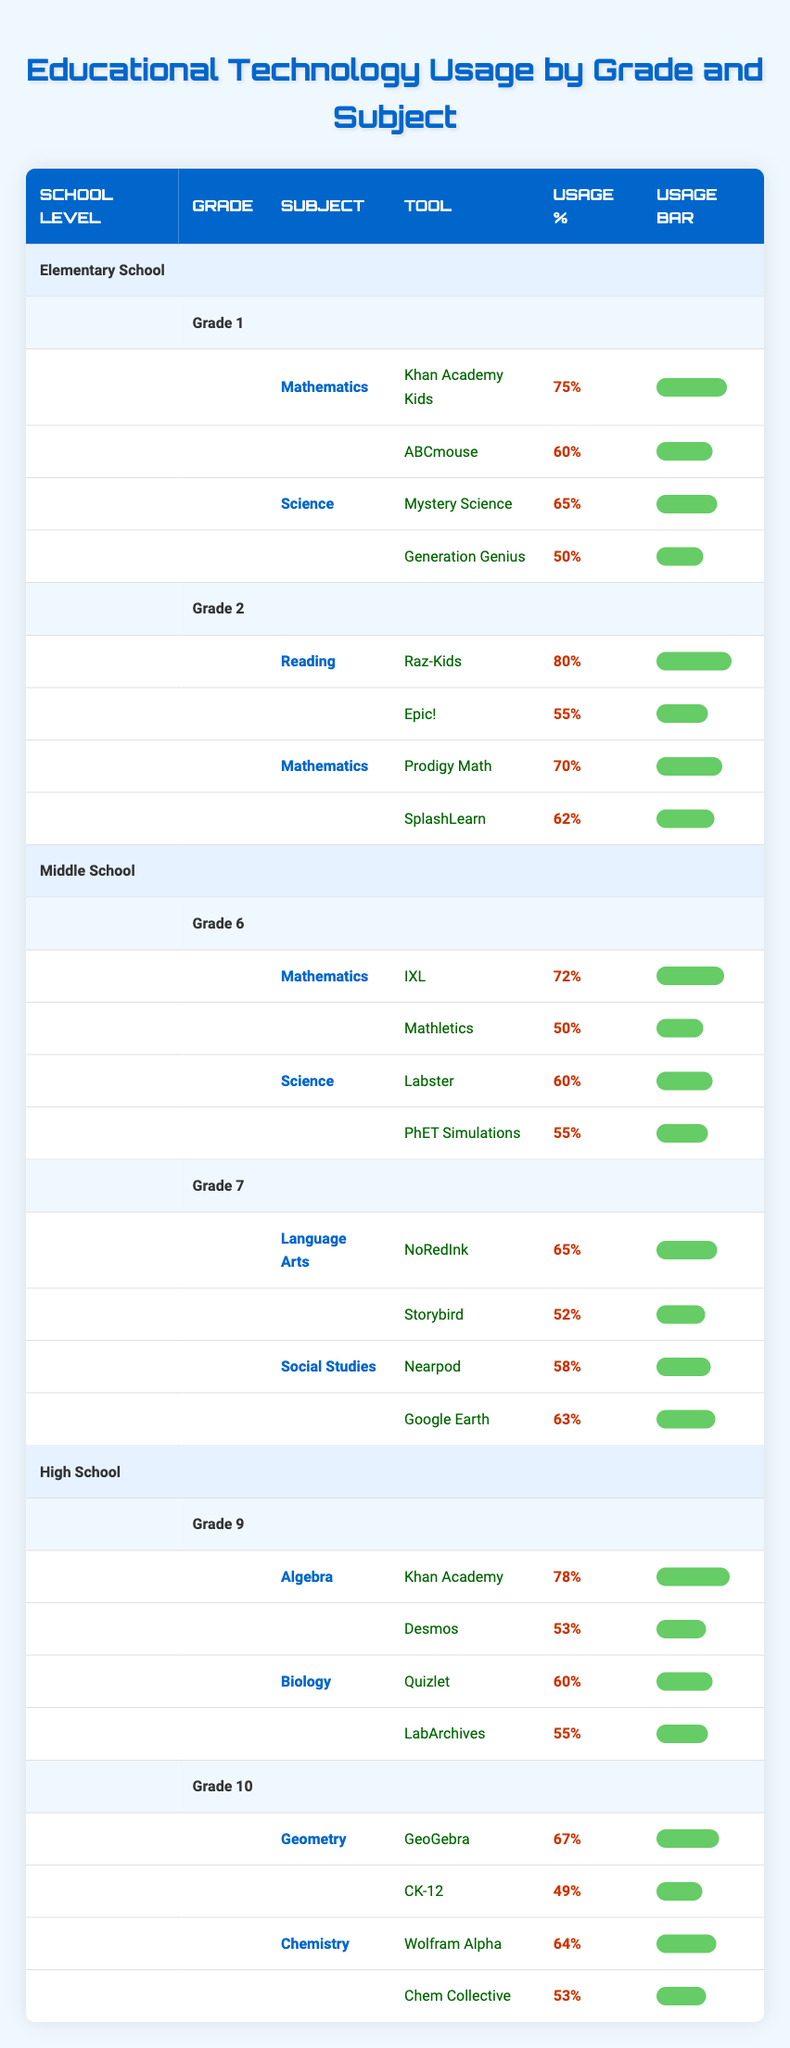What is the usage percentage of Khan Academy Kids in Grade 1 for Mathematics? The table shows that the tool "Khan Academy Kids" has a usage percentage of 75% for the subject Mathematics in Grade 1.
Answer: 75% Which educational tool has the highest usage percentage in Grade 2 Reading? In Grade 2 under the subject Reading, "Raz-Kids" is listed with the highest usage percentage of 80%.
Answer: Raz-Kids Is the usage percentage for SplashLearn greater than or equal to 60%? The table indicates that "SplashLearn" has a usage percentage of 62%, which meets the criterion of being greater than or equal to 60%.
Answer: Yes What is the average usage percentage for the educational tools in Grade 6 Science? For Grade 6 Science, the tools are "Labster" with 60% and "PhET Simulations" with 55%. The average is calculated as (60 + 55) / 2 = 57.5%.
Answer: 57.5% Which tool in Grade 10 Geometry has a lower usage percentage, GeoGebra or CK-12? The table shows that "GeoGebra" has a usage percentage of 67%, while "CK-12" has 49%. Since 49% is less than 67%, CK-12 has the lower usage percentage.
Answer: CK-12 How many tools are used in Grade 7 for Social Studies? The table indicates that there are two tools listed for Grade 7 Social Studies: "Nearpod" and "Google Earth". Therefore, the total number of tools is two.
Answer: 2 What is the total usage percentage for educational tools in Grade 1 combined? In Grade 1, the usage percentages are 75% for "Khan Academy Kids", 60% for "ABCmouse", 65% for "Mystery Science", and 50% for "Generation Genius". Adding them yields 75 + 60 + 65 + 50 = 250%.
Answer: 250% Does the tool LabArchives appear in Middle School? The table lists "LabArchives" under Grade 9 in Biology, confirming that it appears in Middle School.
Answer: Yes 